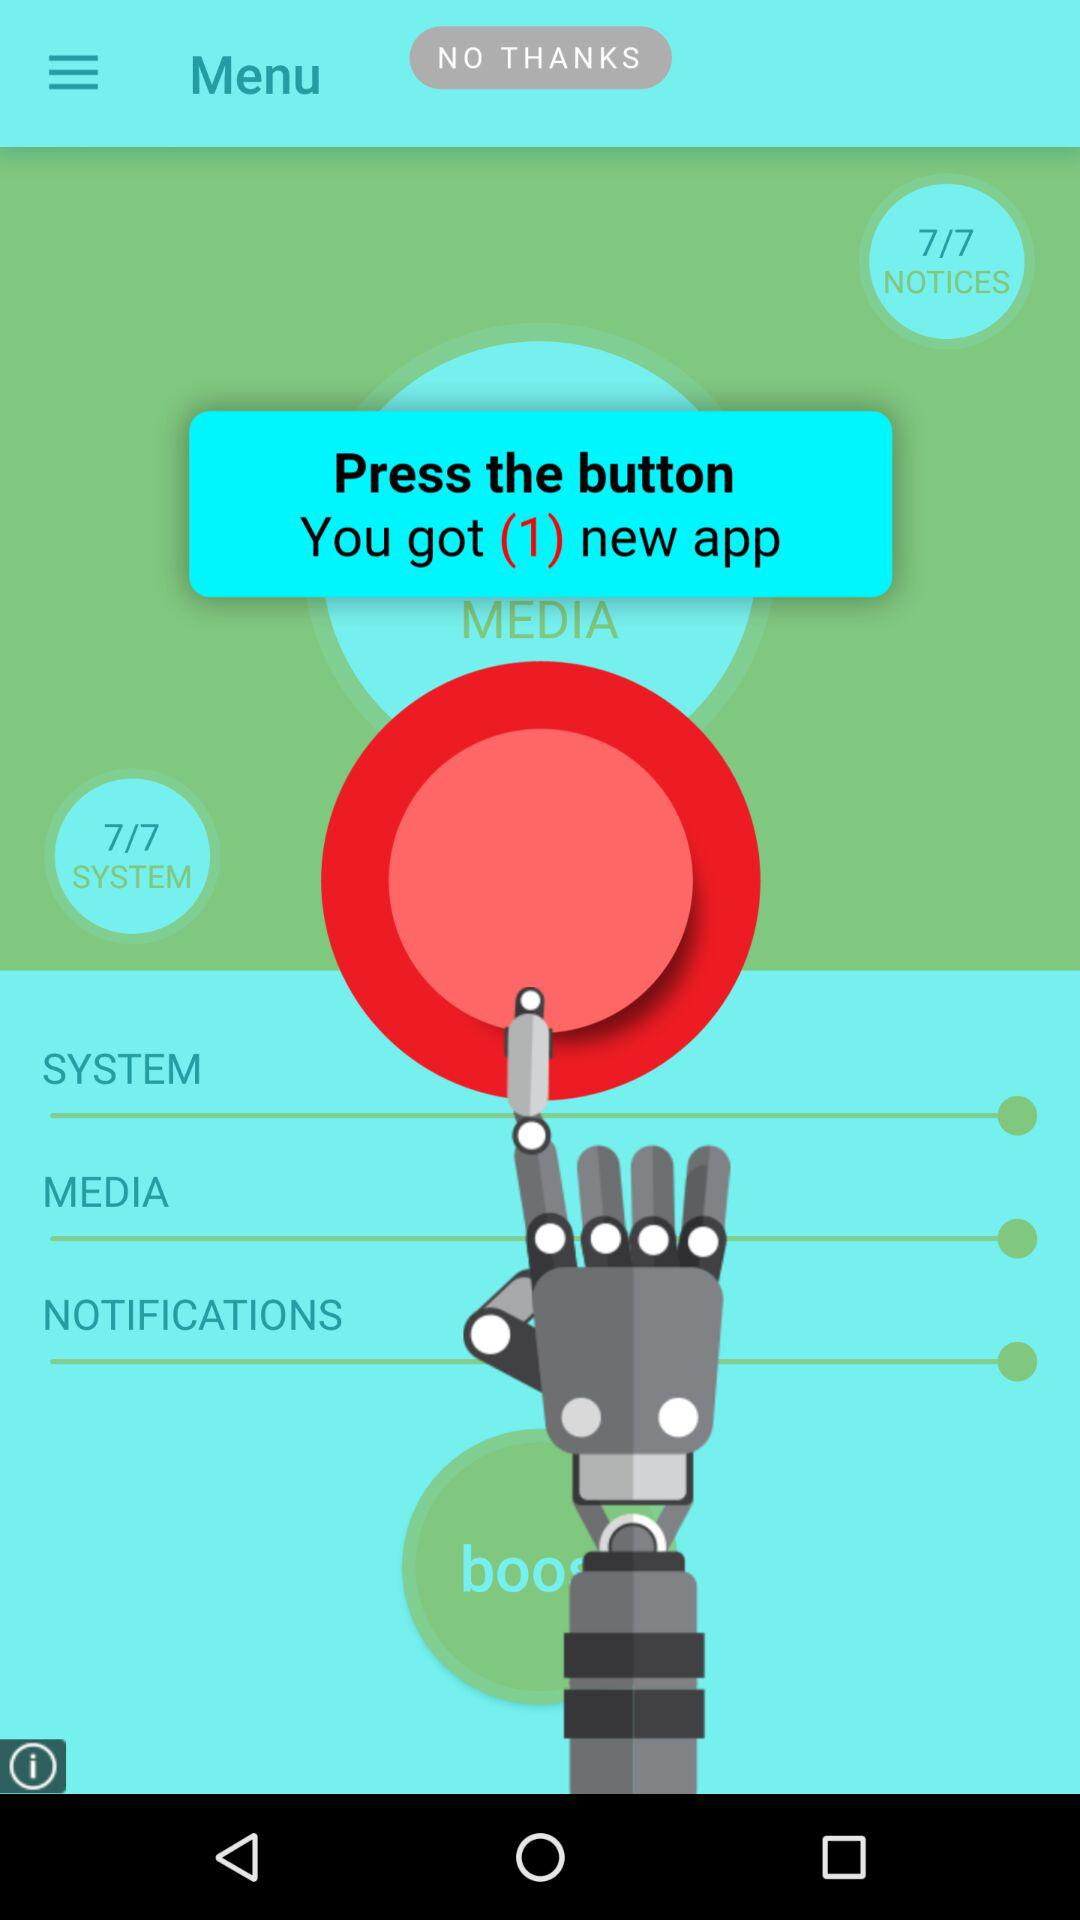What will we get by pressing the button? You will get 1 new app by pressing the button. 